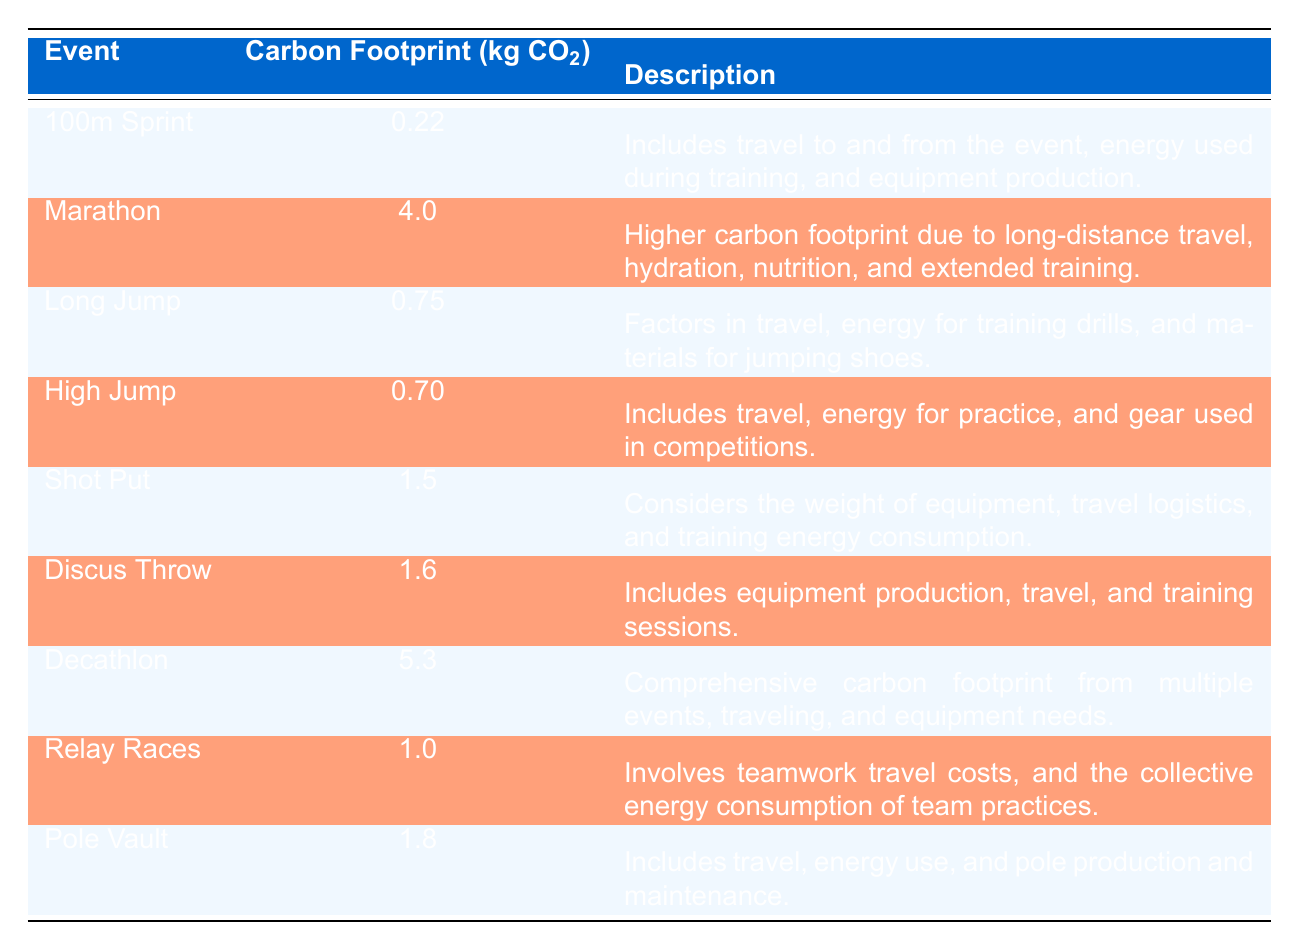What is the carbon footprint of the marathon event? The table states that the average carbon footprint for the marathon event is 4.0 kg CO2.
Answer: 4.0 kg CO2 Which track and field event has the lowest carbon footprint? The event with the lowest carbon footprint is the 100m sprint, which has an average of 0.22 kg CO2.
Answer: 100m sprint How much more carbon dioxide is produced by the decathlon compared to the high jump? The carbon footprint for the decathlon is 5.3 kg CO2, while the high jump is 0.70 kg CO2. The difference is 5.3 - 0.70 = 4.6 kg CO2.
Answer: 4.6 kg CO2 Is the carbon footprint of the shot put greater than the high jump? The shot put's carbon footprint is 1.5 kg CO2 and the high jump is 0.70 kg CO2. Since 1.5 is greater than 0.70, the statement is true.
Answer: Yes Calculate the average carbon footprint of the long jump and pole vault events. The long jump has a footprint of 0.75 kg CO2 and the pole vault has 1.8 kg CO2. The average is (0.75 + 1.8) / 2 = 1.275 kg CO2.
Answer: 1.275 kg CO2 What is the total carbon footprint of the relay races and discus throw? The relay races have a carbon footprint of 1.0 kg CO2, and the discus throw has 1.6 kg CO2. The total is 1.0 + 1.6 = 2.6 kg CO2.
Answer: 2.6 kg CO2 Does the carbon footprint of the long jump exceed 1 kg CO2? The long jump's carbon footprint is 0.75 kg CO2, which does not exceed 1 kg CO2. Hence, the statement is false.
Answer: No Which event produces a carbon footprint closest to 1 kg CO2? The closest event to 1 kg CO2 is the relay races at 1.0 kg CO2.
Answer: Relay races What is the combined carbon footprint of the 100m sprint and high jump? The 100m sprint has a footprint of 0.22 kg CO2 and the high jump has 0.70 kg CO2. The combined footprint is 0.22 + 0.70 = 0.92 kg CO2.
Answer: 0.92 kg CO2 